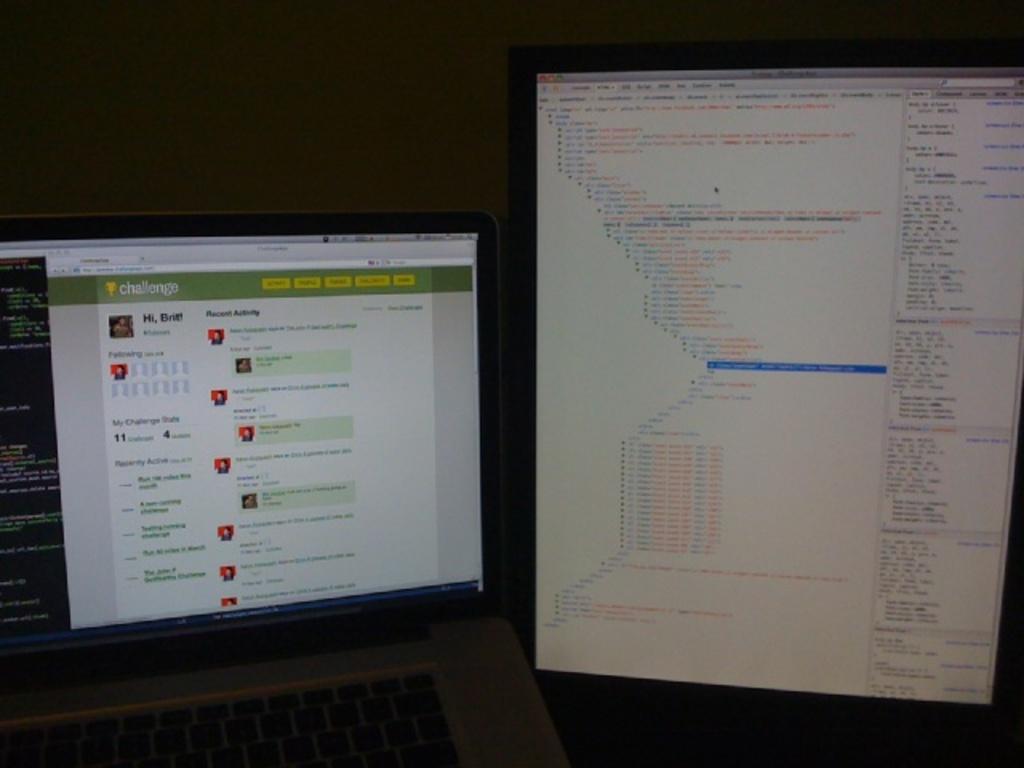What is on the screen on the left?
Your answer should be very brief. Challenge. 